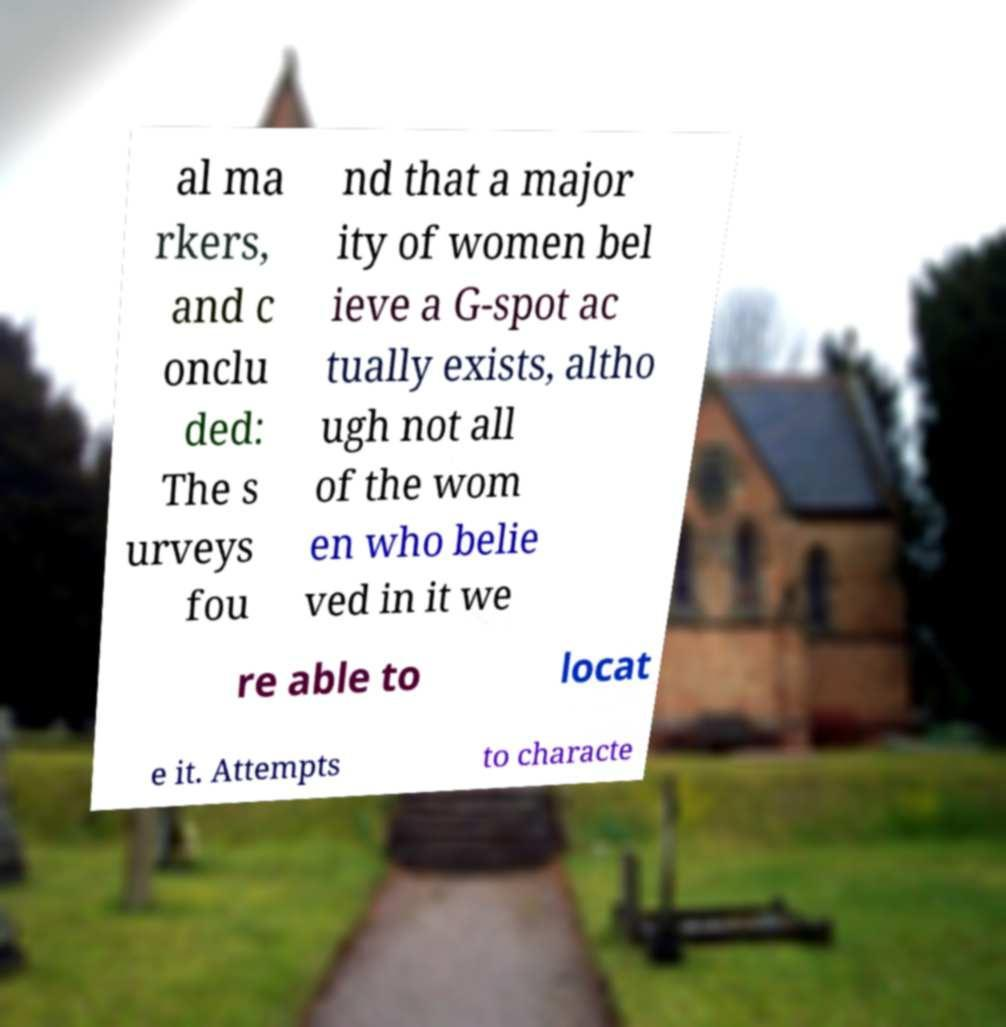There's text embedded in this image that I need extracted. Can you transcribe it verbatim? al ma rkers, and c onclu ded: The s urveys fou nd that a major ity of women bel ieve a G-spot ac tually exists, altho ugh not all of the wom en who belie ved in it we re able to locat e it. Attempts to characte 